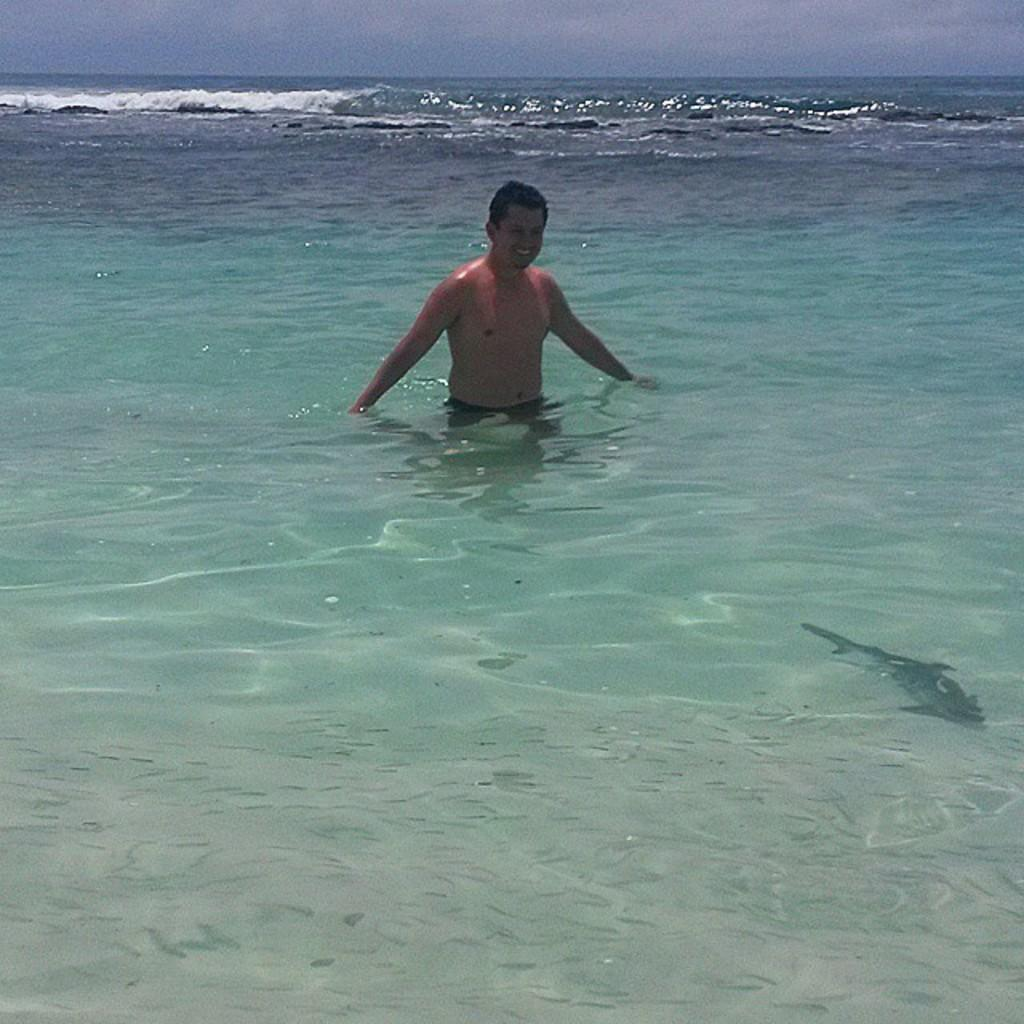What is present in the image that is not solid? There is water in the image. What is the man in the image doing? The man is standing in the water. What can be seen at the top of the image? The sky is visible at the top of the image. What type of magic is the man performing in the water? There is no indication of magic or any magical activity in the image; the man is simply standing in the water. Can you see an arch in the image? There is no arch present in the image. 